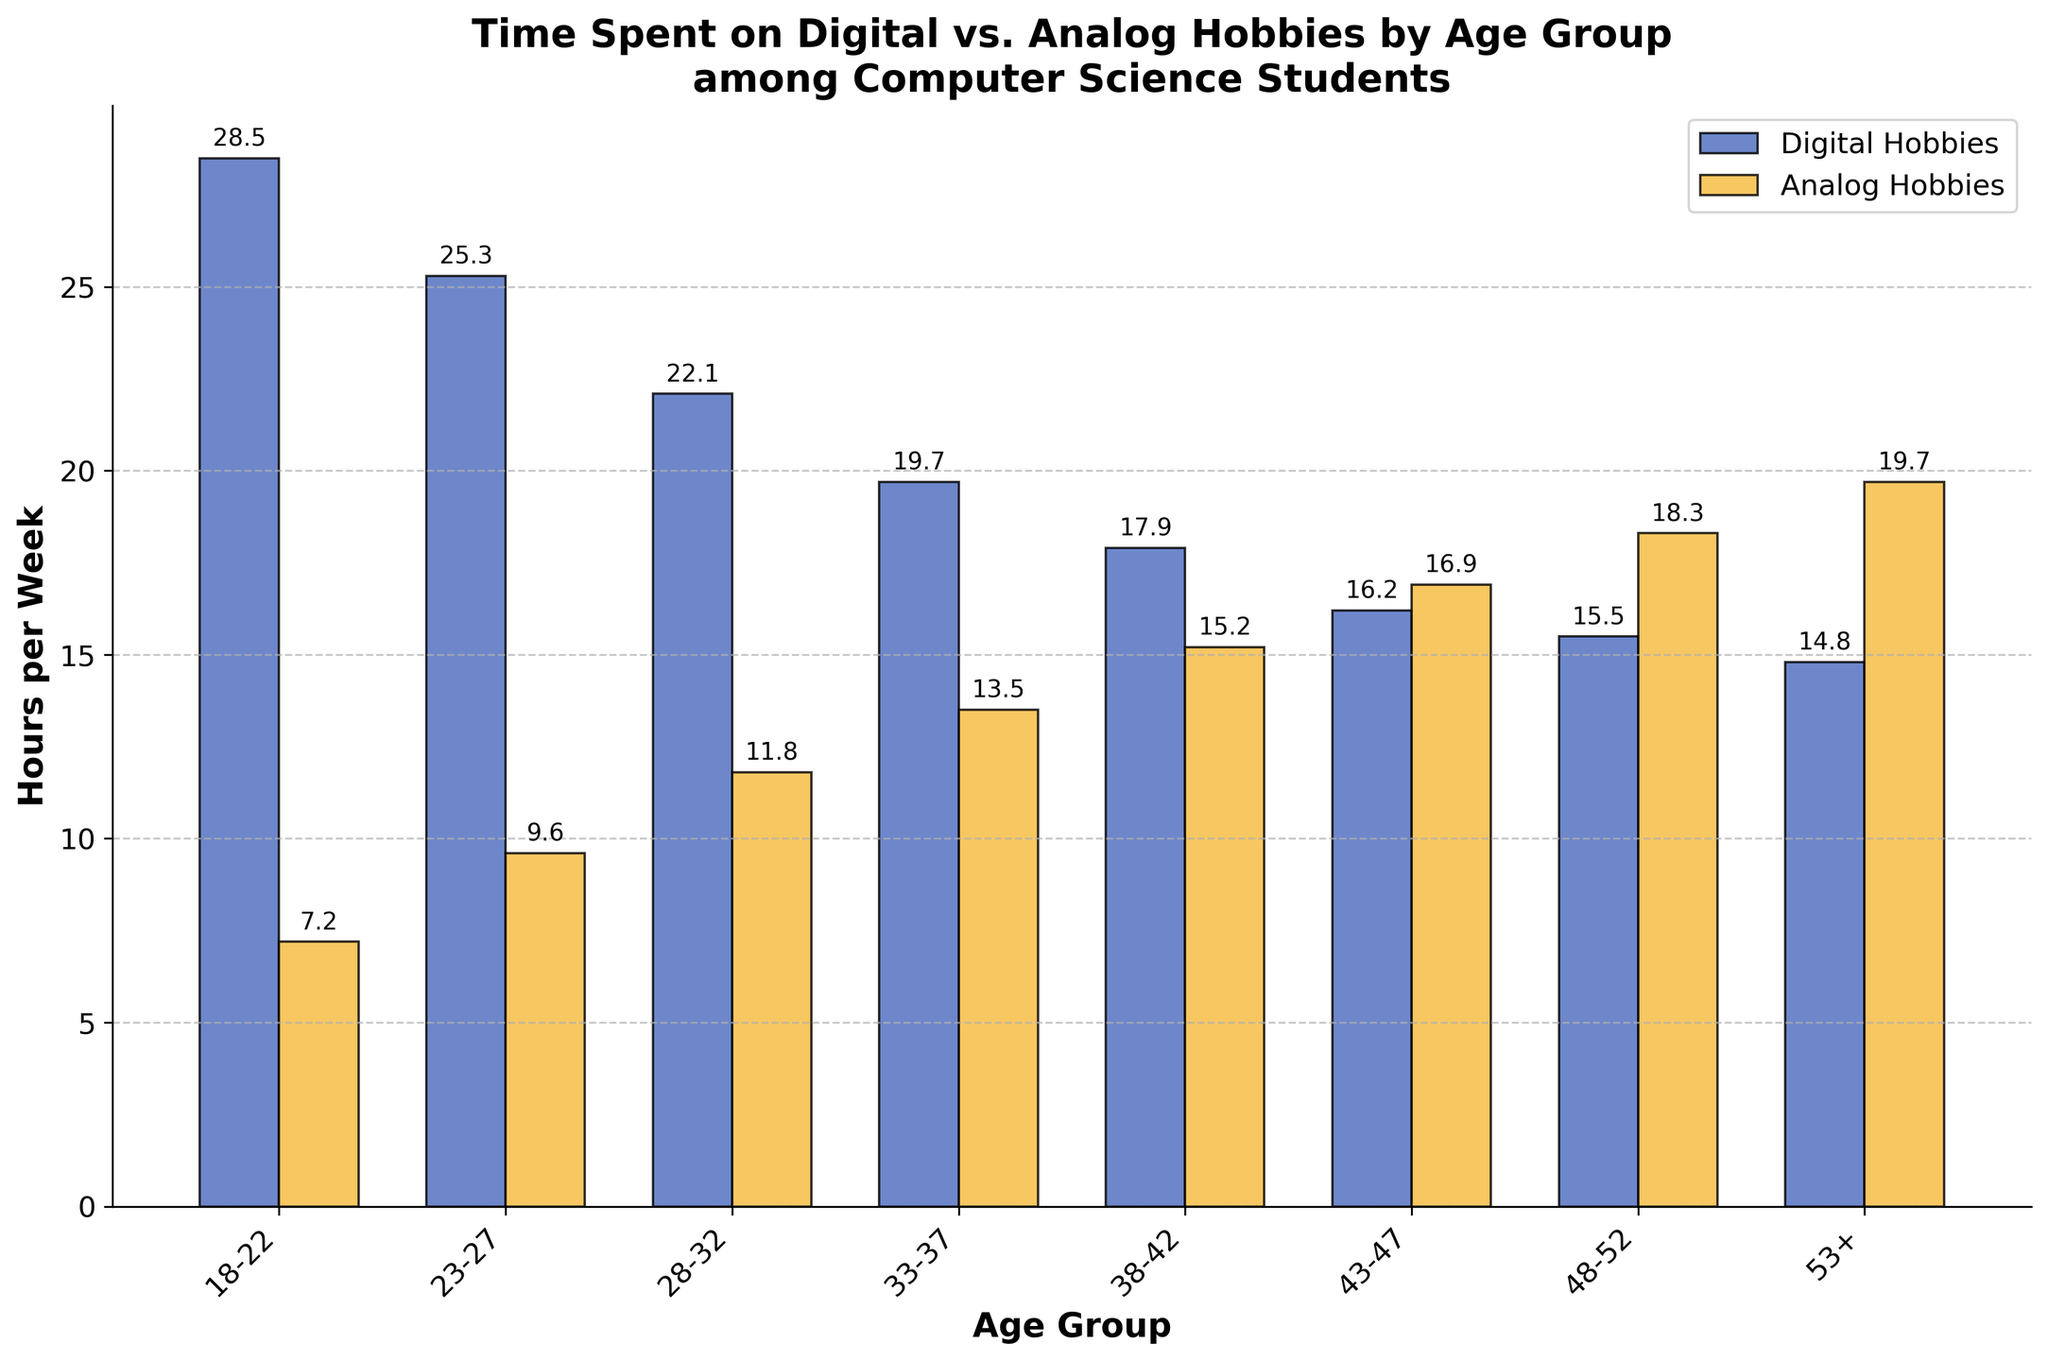which age group spends the most time on digital hobbies? To find the age group that spends the most time on digital hobbies, look at the bar heights for "Digital Hobbies" and identify the tallest bar. The tallest bar represents the 18-22 age group.
Answer: 18-22 which age group spends the most time on analog hobbies? Similarly, to identify the age group that spends the most time on analog hobbies, locate the tallest bar in the "Analog Hobbies" category. The tallest bar represents the 53+ age group.
Answer: 53+ for the age group 33-37, which type of hobby do they spend more time on? Compare the heights of the two bars for the 33-37 age group. The bar for analog hobbies is taller than the bar for digital hobbies.
Answer: Analog Hobbies is there an age group where the time spent on digital and analog hobbies is roughly equal? Look for age groups where the heights of the two bars are nearly the same. The 43-47 age group has bars of similar height, indicating roughly equal time spent on both hobbies.
Answer: 43-47 what is the trend in time spent on digital hobbies as age increases? Observe the bars for digital hobbies across different age groups. The height of the bars decreases as the age groups progress from 18-22 to 53+.
Answer: Decreases how much more time do students aged 23-27 spend on digital hobbies compared to analog hobbies? Subtract the hours for analog hobbies from the hours for digital hobbies in the 23-27 age group: 25.3 - 9.6 = 15.7 hours.
Answer: 15.7 hours which type of hobby shows an increasing trend in time spent as age increases? Observe the trend in bar heights for both types of hobbies. The bars for analog hobbies increase in height from the 18-22 age group to the 53+ age group.
Answer: Analog Hobbies what is the difference in time spent on digital hobbies between the youngest and oldest age groups? Subtract the hours for the 53+ age group from the 18-22 age group: 28.5 - 14.8 = 13.7 hours.
Answer: 13.7 hours is the difference in time spent on analog hobbies between the 48-52 and 53+ age groups greater than 1 hour? Calculate the difference between the two age groups: 19.7 - 18.3 = 1.4 hours, which is greater than 1 hour.
Answer: Yes 